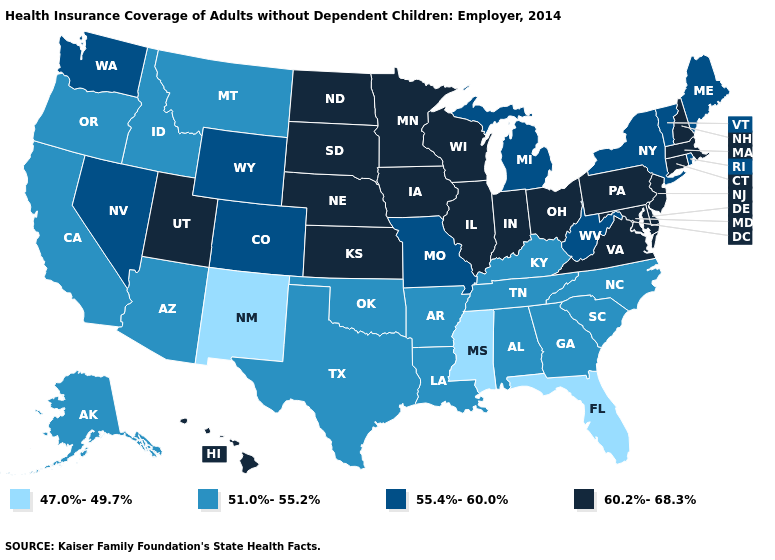Does Rhode Island have a higher value than Ohio?
Answer briefly. No. What is the value of Hawaii?
Be succinct. 60.2%-68.3%. Does Delaware have a higher value than Maryland?
Quick response, please. No. Does Maryland have the same value as Connecticut?
Be succinct. Yes. Name the states that have a value in the range 60.2%-68.3%?
Keep it brief. Connecticut, Delaware, Hawaii, Illinois, Indiana, Iowa, Kansas, Maryland, Massachusetts, Minnesota, Nebraska, New Hampshire, New Jersey, North Dakota, Ohio, Pennsylvania, South Dakota, Utah, Virginia, Wisconsin. What is the highest value in states that border Utah?
Quick response, please. 55.4%-60.0%. Name the states that have a value in the range 60.2%-68.3%?
Concise answer only. Connecticut, Delaware, Hawaii, Illinois, Indiana, Iowa, Kansas, Maryland, Massachusetts, Minnesota, Nebraska, New Hampshire, New Jersey, North Dakota, Ohio, Pennsylvania, South Dakota, Utah, Virginia, Wisconsin. Name the states that have a value in the range 55.4%-60.0%?
Short answer required. Colorado, Maine, Michigan, Missouri, Nevada, New York, Rhode Island, Vermont, Washington, West Virginia, Wyoming. Does the first symbol in the legend represent the smallest category?
Quick response, please. Yes. Does Rhode Island have a higher value than Vermont?
Be succinct. No. Which states have the lowest value in the USA?
Write a very short answer. Florida, Mississippi, New Mexico. Does the map have missing data?
Short answer required. No. What is the highest value in states that border Delaware?
Short answer required. 60.2%-68.3%. What is the value of New York?
Concise answer only. 55.4%-60.0%. Does the first symbol in the legend represent the smallest category?
Be succinct. Yes. 